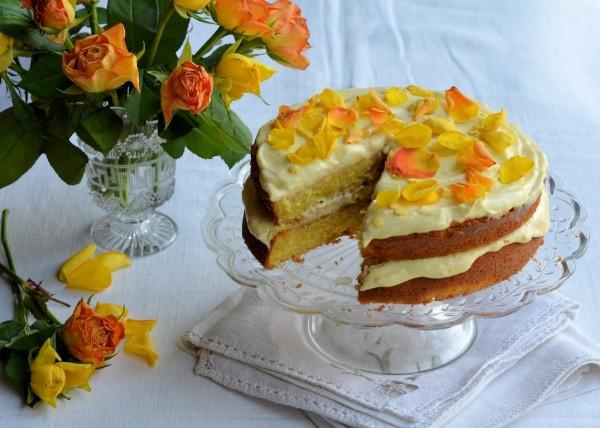Is it in a plate or carton?
Short answer required. Plate. What event are the people celebrating?
Answer briefly. Wedding. Are the petals decorating the cake edible?
Concise answer only. Yes. What kind of flowers are in this picture?
Be succinct. Roses. How many desserts are on the doily?
Concise answer only. 1. What color is the tablecloth?
Write a very short answer. White. 